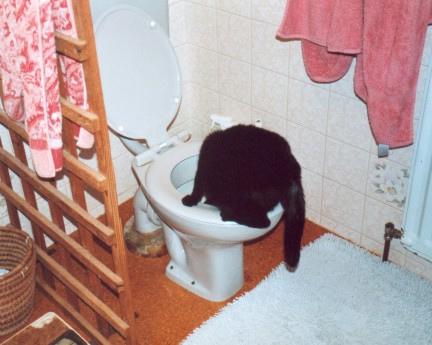What is the cat drinking out of?
Keep it brief. Toilet. What color is the kitty?
Write a very short answer. Black. What color towel is hanging on the right?
Give a very brief answer. Pink. 